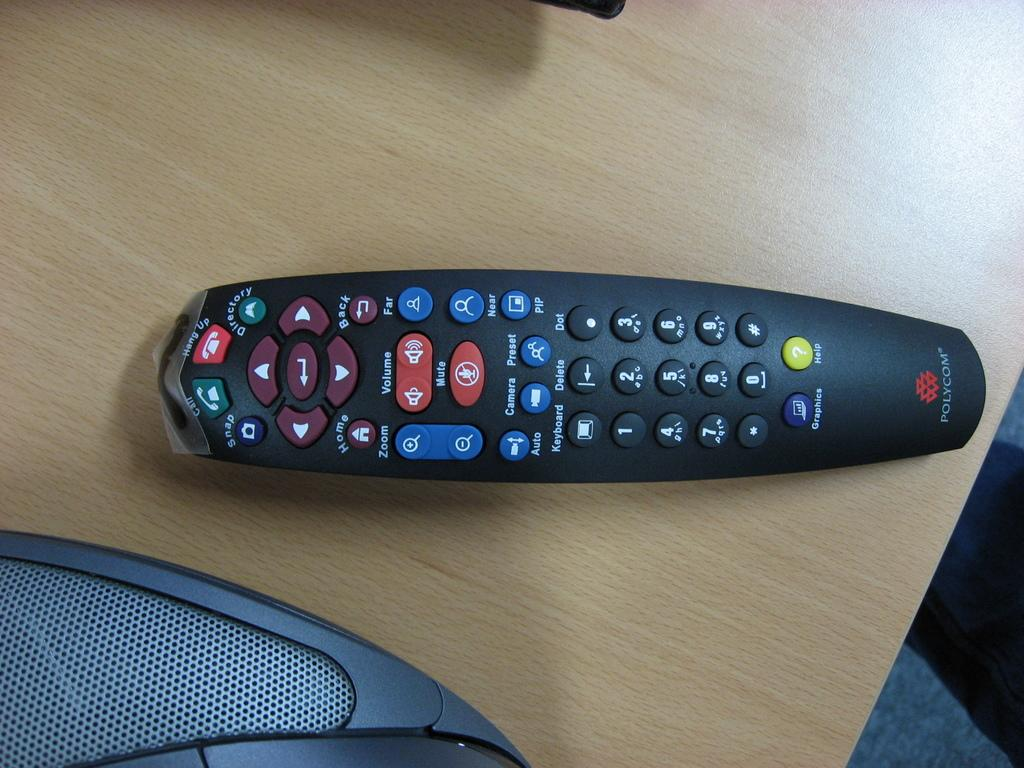<image>
Describe the image concisely. a remote that has polycom written at the bottom of it 